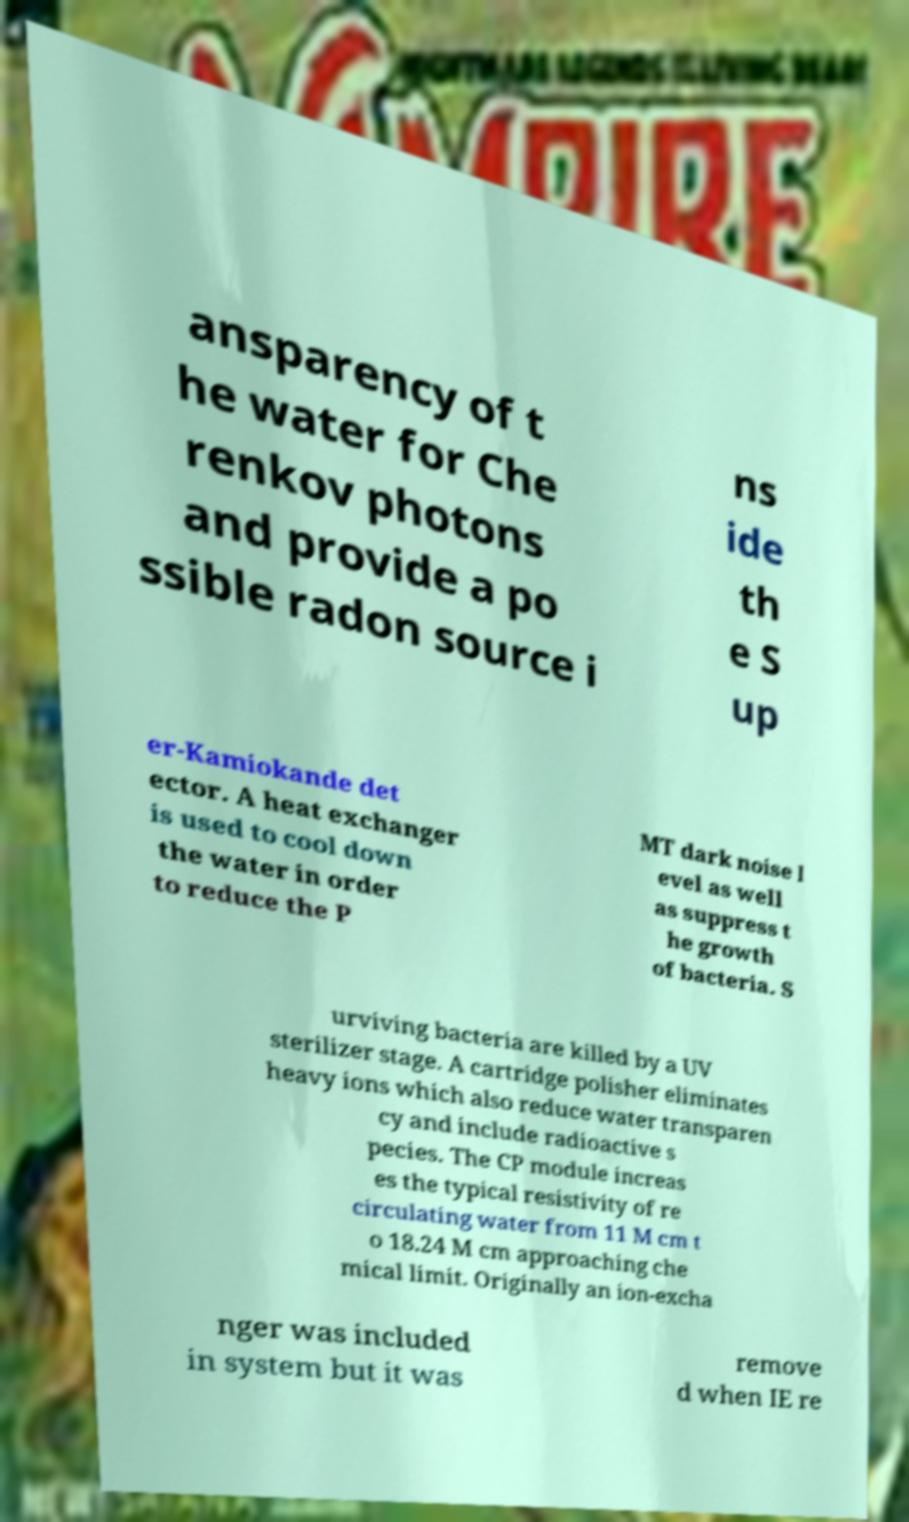Please read and relay the text visible in this image. What does it say? ansparency of t he water for Che renkov photons and provide a po ssible radon source i ns ide th e S up er-Kamiokande det ector. A heat exchanger is used to cool down the water in order to reduce the P MT dark noise l evel as well as suppress t he growth of bacteria. S urviving bacteria are killed by a UV sterilizer stage. A cartridge polisher eliminates heavy ions which also reduce water transparen cy and include radioactive s pecies. The CP module increas es the typical resistivity of re circulating water from 11 M cm t o 18.24 M cm approaching che mical limit. Originally an ion-excha nger was included in system but it was remove d when IE re 